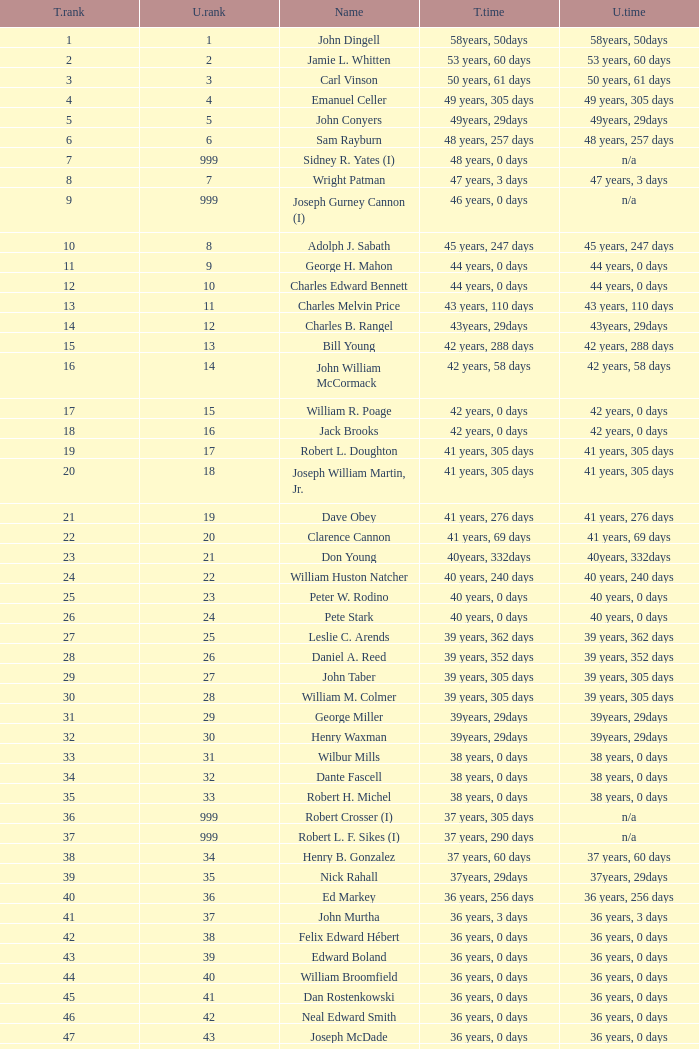How many uninterrupted ranks does john dingell have? 1.0. 